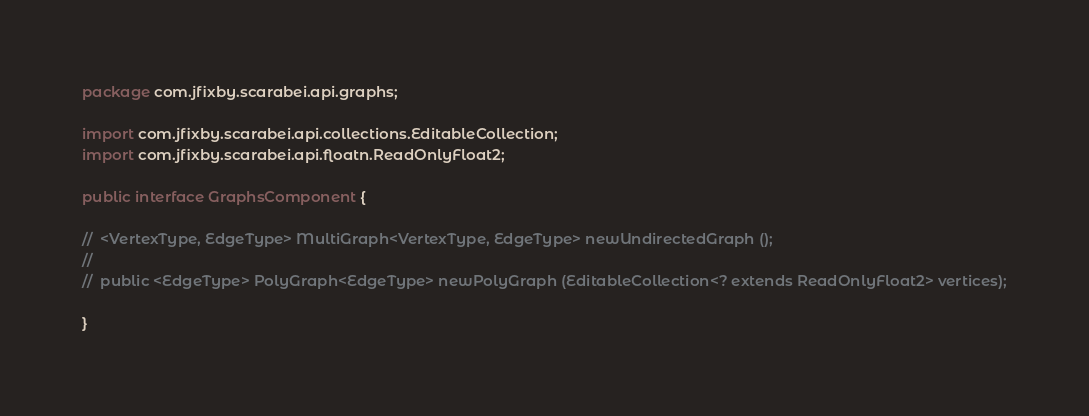<code> <loc_0><loc_0><loc_500><loc_500><_Java_>
package com.jfixby.scarabei.api.graphs;

import com.jfixby.scarabei.api.collections.EditableCollection;
import com.jfixby.scarabei.api.floatn.ReadOnlyFloat2;

public interface GraphsComponent {

//	<VertexType, EdgeType> MultiGraph<VertexType, EdgeType> newUndirectedGraph ();
//
//	public <EdgeType> PolyGraph<EdgeType> newPolyGraph (EditableCollection<? extends ReadOnlyFloat2> vertices);

}
</code> 